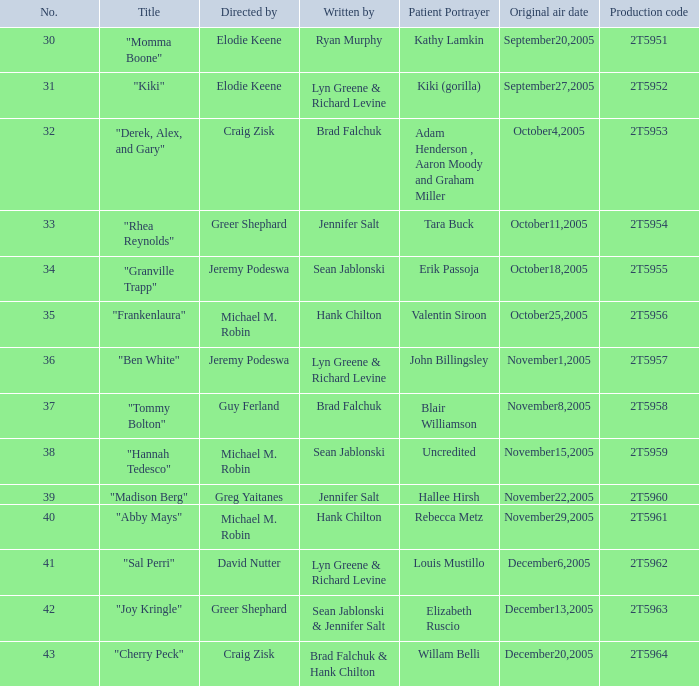What is the overall count of patient portrayers in the episode directed by craig zisk and penned by brad falchuk? 1.0. 